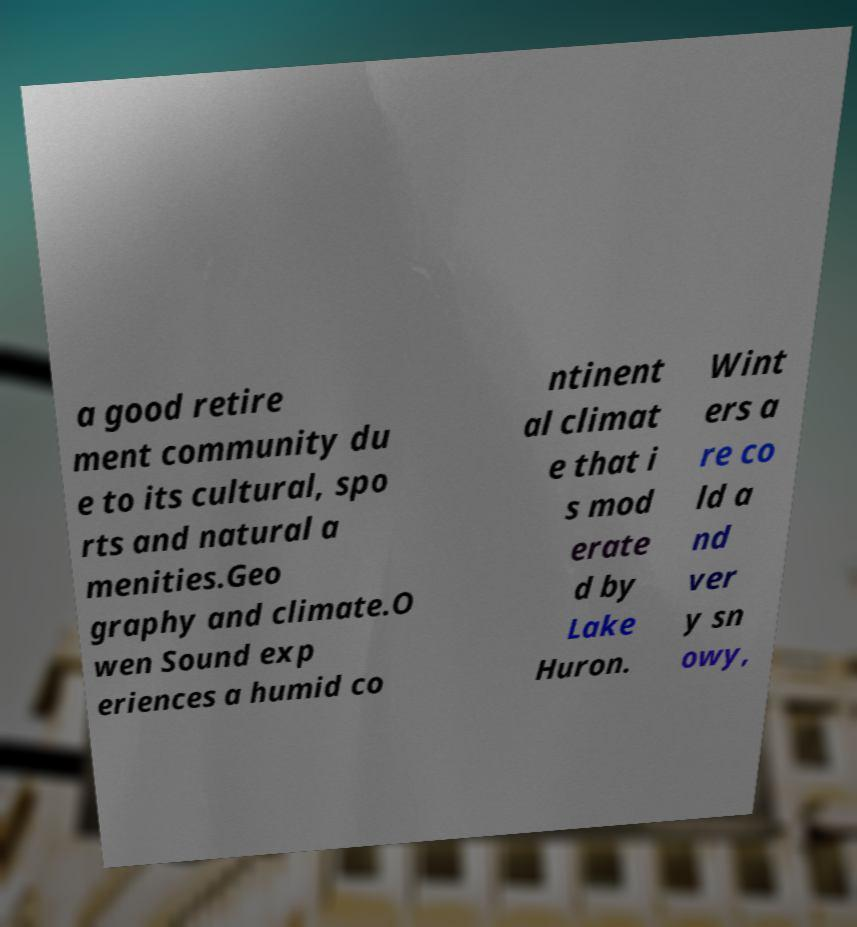There's text embedded in this image that I need extracted. Can you transcribe it verbatim? a good retire ment community du e to its cultural, spo rts and natural a menities.Geo graphy and climate.O wen Sound exp eriences a humid co ntinent al climat e that i s mod erate d by Lake Huron. Wint ers a re co ld a nd ver y sn owy, 